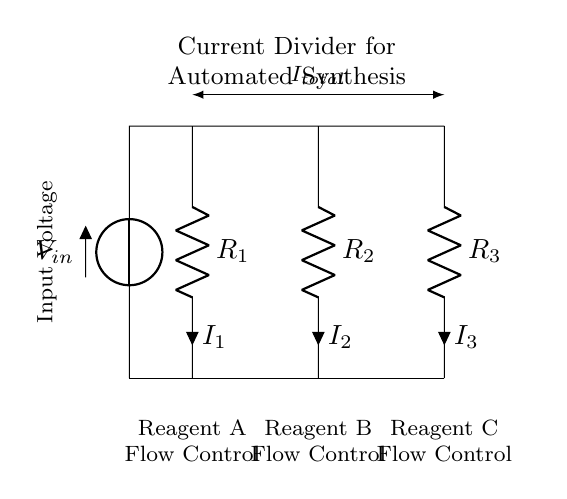What is the input voltage of this circuit? The input voltage is labeled as \( V_{in} \), which indicates the voltage supplied to the circuit.
Answer: V_in How many resistors are present in this circuit? The circuit diagram clearly shows three resistors, labeled \( R_1 \), \( R_2 \), and \( R_3 \), indicating that there are a total of three resistors.
Answer: 3 What is the current flowing through resistor \( R_2 \)? The current through resistor \( R_2 \) is denoted as \( I_2 \) in the circuit diagram, specifying the current that traverses this resistor.
Answer: I_2 What is the total current represented in the circuit? The total current is indicated as \( I_{total} \), which is represented above the resistors and symbolizes the combined current entering the parallel configuration of the resistors.
Answer: I_total Which reagent flow control is associated with resistor \( R_3 \)? Resistor \( R_3 \) is labeled with "Reagent C Flow Control," indicating that this resistor is responsible for regulating the flow rate of Reagent C in the automated synthesis system.
Answer: Reagent C Flow Control If the resistors are equal, what is the current through each resistor? In a current divider with equal resistors, the current splits evenly among the resistors. Thus, if the total current is \( I_{total} \), each resistor would have a current of \( I_{total}/3 \). Calculating this requires knowledge of the total current, but the principle indicates equal division for equal resistors.
Answer: I_total/3 Why is a current divider used in automated synthesis systems? A current divider is utilized in this context to achieve precise control over the flow rates of multiple reagents. By adjusting the resistance values, the current can be proportioned, facilitating accurate mixing ratios essential for successful chemical synthesis.
Answer: Precise control of flow rates 